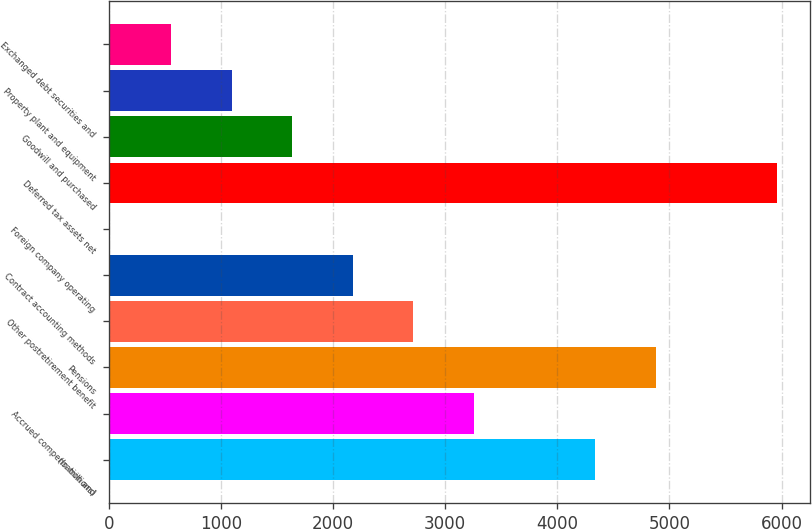Convert chart to OTSL. <chart><loc_0><loc_0><loc_500><loc_500><bar_chart><fcel>(In millions)<fcel>Accrued compensation and<fcel>Pensions<fcel>Other postretirement benefit<fcel>Contract accounting methods<fcel>Foreign company operating<fcel>Deferred tax assets net<fcel>Goodwill and purchased<fcel>Property plant and equipment<fcel>Exchanged debt securities and<nl><fcel>4337.4<fcel>3256.8<fcel>4877.7<fcel>2716.5<fcel>2176.2<fcel>15<fcel>5958.3<fcel>1635.9<fcel>1095.6<fcel>555.3<nl></chart> 